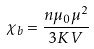<formula> <loc_0><loc_0><loc_500><loc_500>\chi _ { b } = \frac { n \mu _ { 0 } \mu ^ { 2 } } { 3 K V }</formula> 